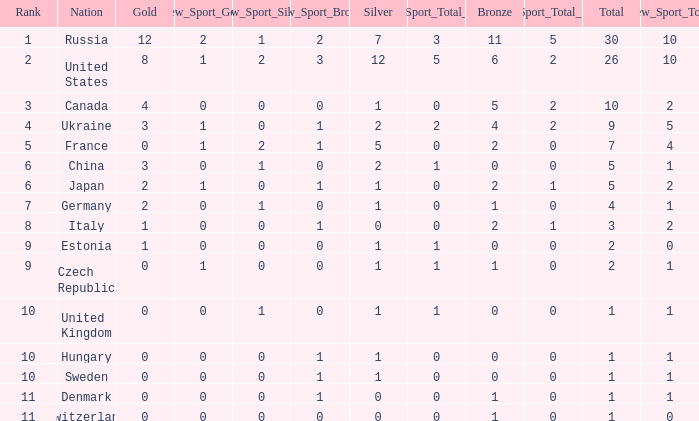Which silver has a Gold smaller than 12, a Rank smaller than 5, and a Bronze of 5? 1.0. 